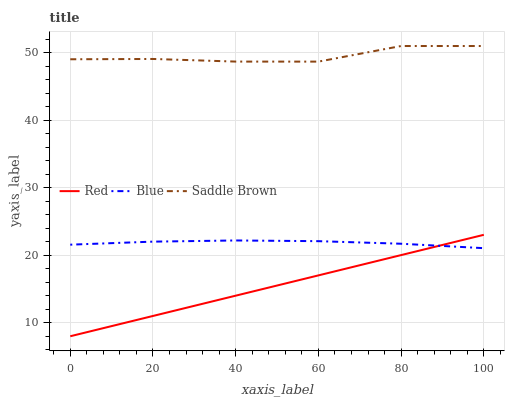Does Red have the minimum area under the curve?
Answer yes or no. Yes. Does Saddle Brown have the maximum area under the curve?
Answer yes or no. Yes. Does Saddle Brown have the minimum area under the curve?
Answer yes or no. No. Does Red have the maximum area under the curve?
Answer yes or no. No. Is Red the smoothest?
Answer yes or no. Yes. Is Saddle Brown the roughest?
Answer yes or no. Yes. Is Saddle Brown the smoothest?
Answer yes or no. No. Is Red the roughest?
Answer yes or no. No. Does Red have the lowest value?
Answer yes or no. Yes. Does Saddle Brown have the lowest value?
Answer yes or no. No. Does Saddle Brown have the highest value?
Answer yes or no. Yes. Does Red have the highest value?
Answer yes or no. No. Is Blue less than Saddle Brown?
Answer yes or no. Yes. Is Saddle Brown greater than Blue?
Answer yes or no. Yes. Does Blue intersect Red?
Answer yes or no. Yes. Is Blue less than Red?
Answer yes or no. No. Is Blue greater than Red?
Answer yes or no. No. Does Blue intersect Saddle Brown?
Answer yes or no. No. 